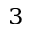<formula> <loc_0><loc_0><loc_500><loc_500>_ { 3 }</formula> 